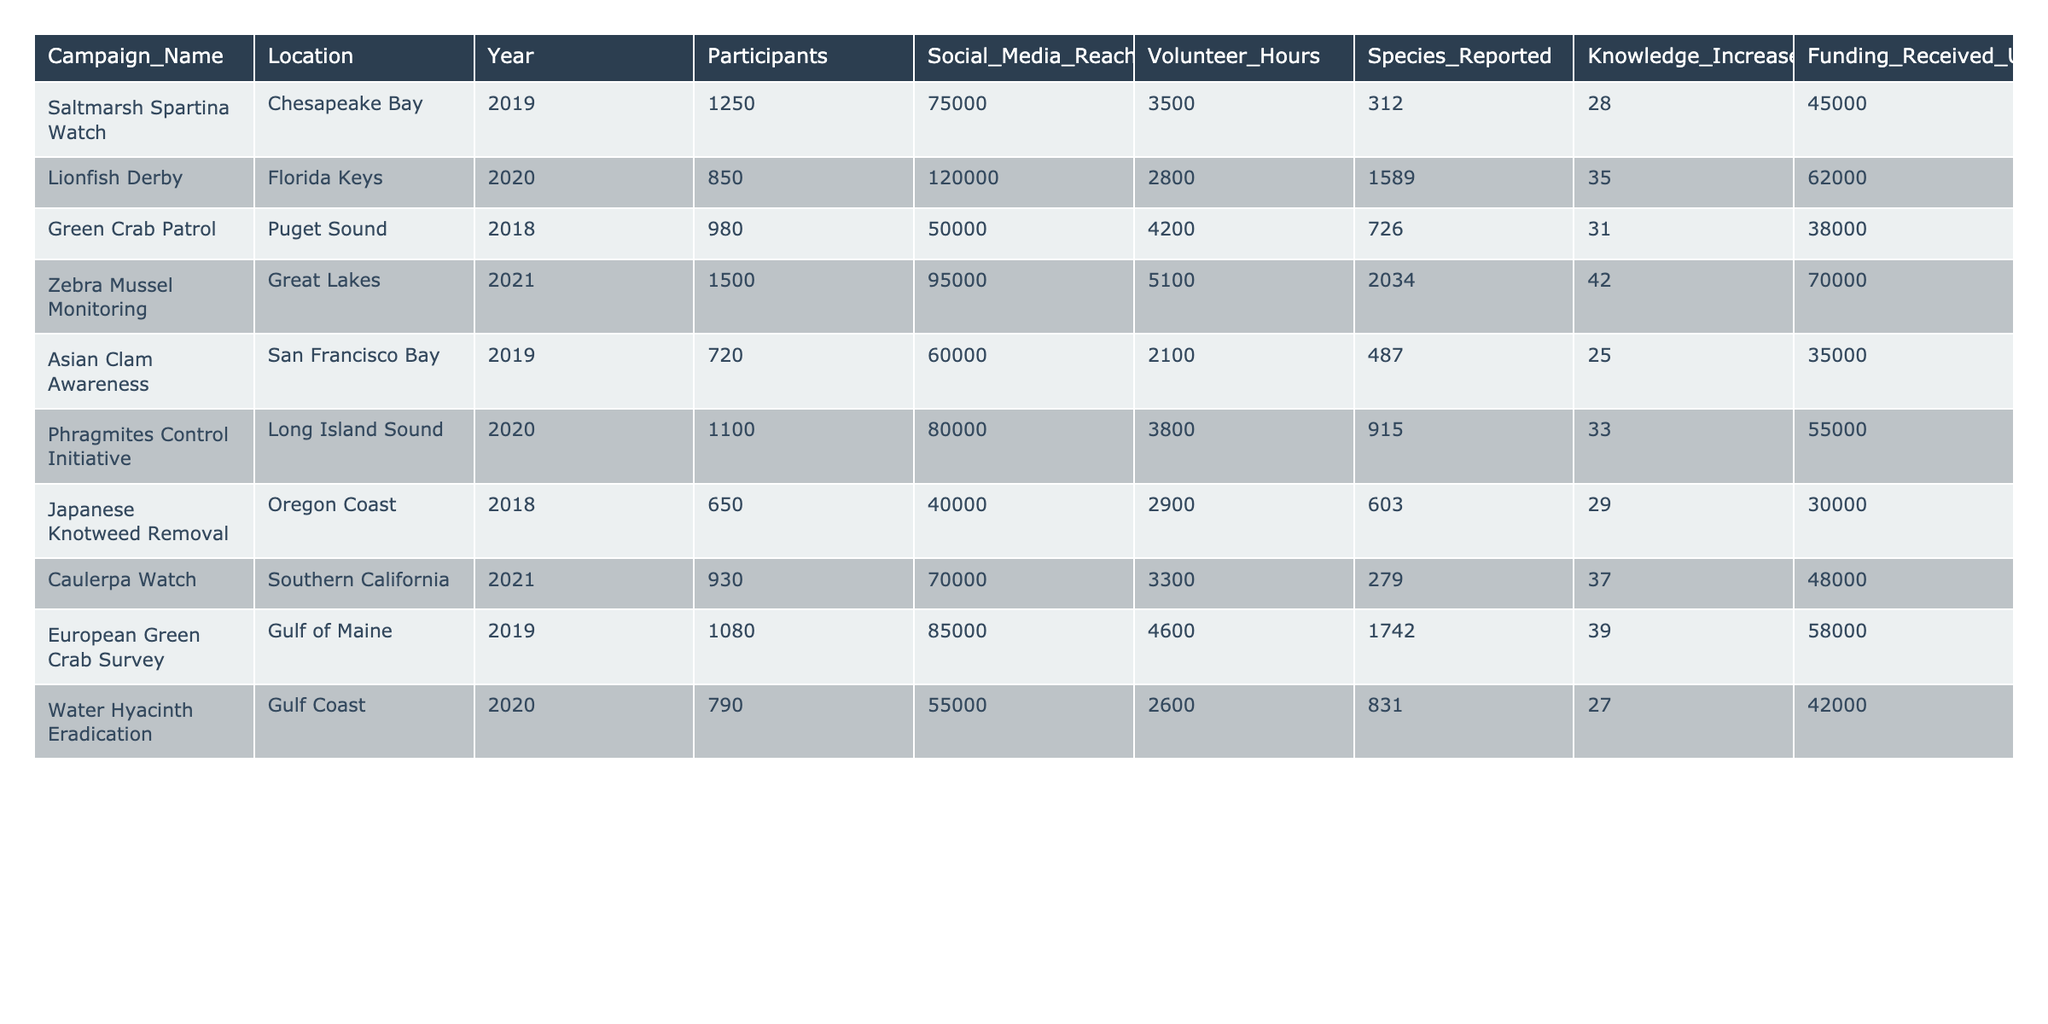What is the total number of participants across all campaigns? To find the total number of participants, sum the values from the 'Participants' column: 1250 + 850 + 980 + 1500 + 720 + 1100 + 650 + 930 + 1080 + 790 =  10000
Answer: 10000 Which campaign had the highest social media reach? The 'Social_Media_Reach' for each campaign is compared, and 'Lionfish Derby' has the highest value at 120000.
Answer: Lionfish Derby How many species were reported in total during all campaigns? Sum the 'Species_Reported' column: 312 + 1589 + 726 + 2034 + 487 + 915 + 603 + 279 + 1742 + 831 =  1313
Answer: 1313 Is there a campaign that resulted in a knowledge increase percentage of over 40%? Check the 'Knowledge_Increase_Percentage' column for values greater than 40%. 'Zebra Mussel Monitoring' (42) meets this criterion.
Answer: Yes What is the average funding received for campaigns from the Gulf Coast region? The campaign 'Water Hyacinth Eradication' received 42000. Since it's the only campaign from the Gulf Coast, the average is the same as the funding received: 42000/1 = 42000
Answer: 42000 Which campaign had the lowest volunteer hours, and what was that figure? Identify the 'Volunteer_Hours' for each campaign. 'Water Hyacinth Eradication' had the lowest volunteer hours at 2600.
Answer: 2600 What is the total knowledge increase percentage across all campaigns? To find the total, sum the 'Knowledge_Increase_Percentage' values: 28 + 35 + 31 + 42 + 25 + 33 + 29 + 37 + 39 + 27 =  317
Answer: 317 Which region had the most campaigns listed in the table? Count campaigns by region; Coastal regions include 'Chesapeake Bay,' 'Florida Keys,' 'Puget Sound,' 'Great Lakes,' etc. Each has one campaign, so no region exceeds the others in count.
Answer: None How much funding was received by the campaign with the second highest social media reach? The campaign with the second highest social media reach is 'Zebra Mussel Monitoring' (95000) with funding of 70000.
Answer: 70000 Is there a correlation between the number of participants and the funding received? Analyze the 'Participants' and 'Funding_Received_USD' columns to determine the relationship; generally, more participants correlate with higher funding as seen in the values.
Answer: Yes 